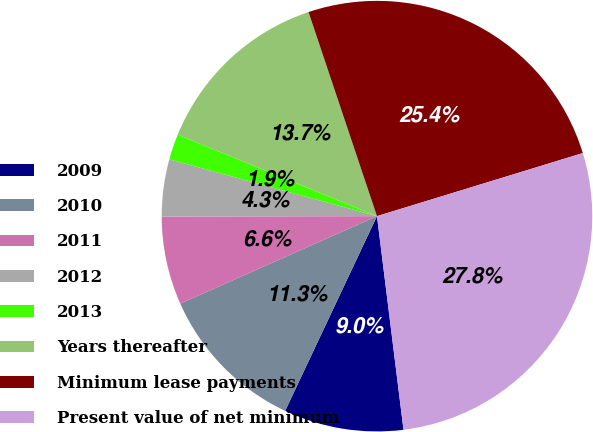Convert chart. <chart><loc_0><loc_0><loc_500><loc_500><pie_chart><fcel>2009<fcel>2010<fcel>2011<fcel>2012<fcel>2013<fcel>Years thereafter<fcel>Minimum lease payments<fcel>Present value of net minimum<nl><fcel>8.98%<fcel>11.33%<fcel>6.63%<fcel>4.28%<fcel>1.93%<fcel>13.67%<fcel>25.42%<fcel>27.77%<nl></chart> 